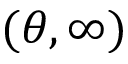<formula> <loc_0><loc_0><loc_500><loc_500>( \theta , \infty )</formula> 